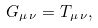<formula> <loc_0><loc_0><loc_500><loc_500>G _ { \mu \, \nu } = T _ { \mu \, \nu } ,</formula> 